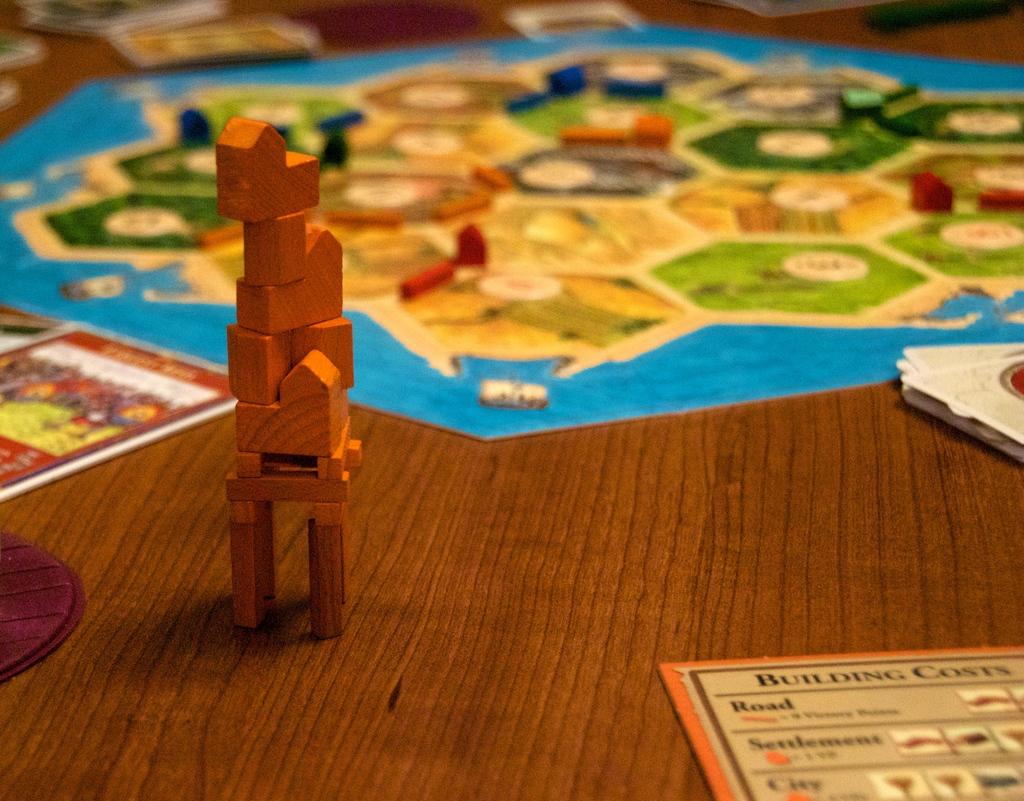What is the first word on the card in the bottom right?
Give a very brief answer. Building. 